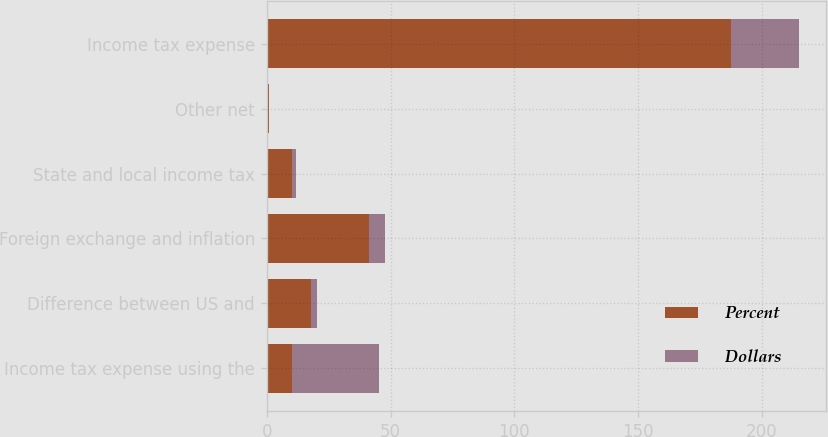Convert chart to OTSL. <chart><loc_0><loc_0><loc_500><loc_500><stacked_bar_chart><ecel><fcel>Income tax expense using the<fcel>Difference between US and<fcel>Foreign exchange and inflation<fcel>State and local income tax<fcel>Other net<fcel>Income tax expense<nl><fcel>Percent<fcel>10.3<fcel>17.8<fcel>41.4<fcel>10.3<fcel>0.8<fcel>187.3<nl><fcel>Dollars<fcel>35<fcel>2.6<fcel>6.2<fcel>1.5<fcel>0.1<fcel>27.8<nl></chart> 